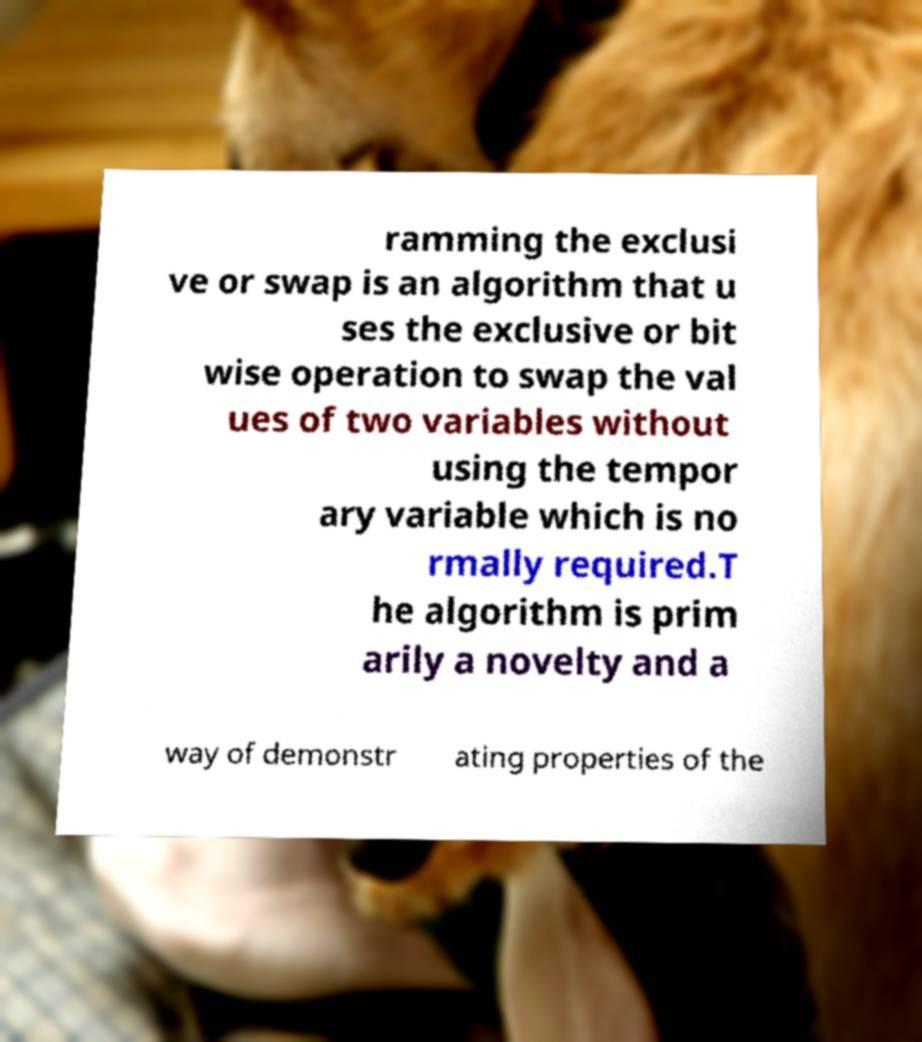Could you assist in decoding the text presented in this image and type it out clearly? ramming the exclusi ve or swap is an algorithm that u ses the exclusive or bit wise operation to swap the val ues of two variables without using the tempor ary variable which is no rmally required.T he algorithm is prim arily a novelty and a way of demonstr ating properties of the 